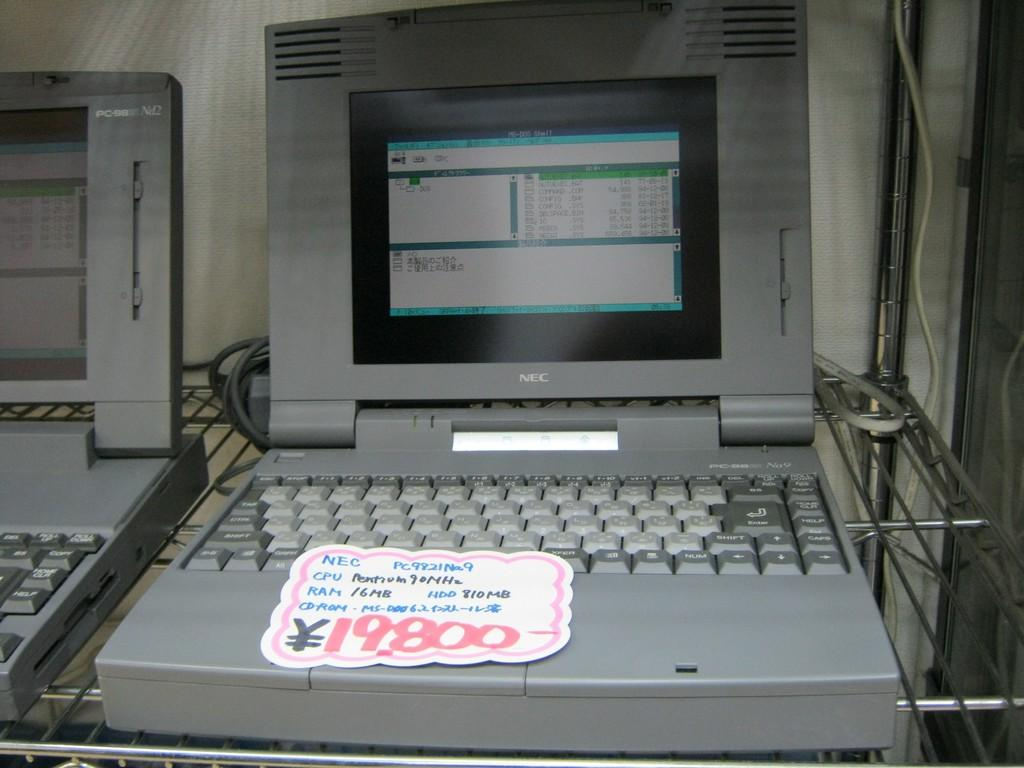Provide a one-sentence caption for the provided image. A old NEC computer is selling at 19,800 yen. 